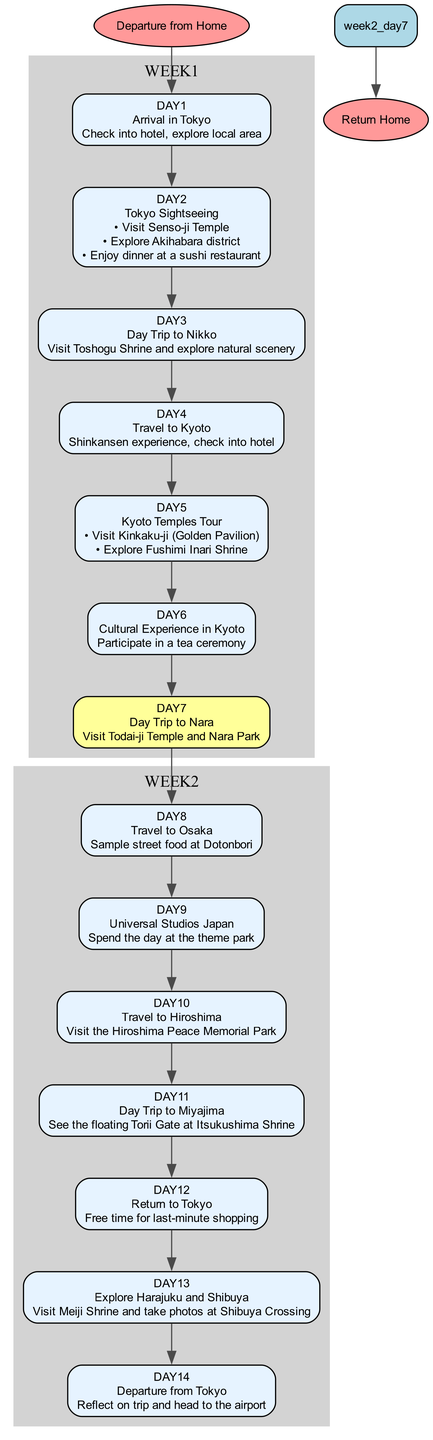What is the first activity in the itinerary? The diagram starts with the node labeled "day1" in week1, indicating the first activity is "Arrival in Tokyo".
Answer: Arrival in Tokyo How many days are planned in the itinerary? The itinerary consists of two weeks, with seven days in week1 and seven days in week2, totaling 14 days.
Answer: 14 days What activity follows the Kyoto Temples Tour? The diagram shows the flow from "week1_day5" (Kyoto Temples Tour) to "week1_day6", which details the next activity as "Cultural Experience in Kyoto".
Answer: Cultural Experience in Kyoto Which destination has a street food experience? Looking at week2, "day8" specifies "Travel to Osaka" and mentions "Sample street food at Dotonbori".
Answer: Osaka What is the last activity before returning home? The diagram indicates that the day before departure from Tokyo is "day13", which includes "Explore Harajuku and Shibuya".
Answer: Explore Harajuku and Shibuya How many activities are in the Kyoto Temples Tour? Specifically analyzing "day5" in week1, it lists two main activities: visiting Kinkaku-ji and Fushimi Inari Shrine. Thus, there are two activities mentioned.
Answer: 2 activities What is the relationship between the Tokyo Sightseeing and Day Trip to Nikko? Observing the flow, "Tokyo Sightseeing" (day2) leads directly to "Day Trip to Nikko" (day3), indicating that they are consecutive activities in the itinerary.
Answer: Consective activities What color represents the activities in week1? Upon examining the diagram, all nodes representing activities in week1 are colored light blue according to the attribute settings in the graph.
Answer: Light blue 